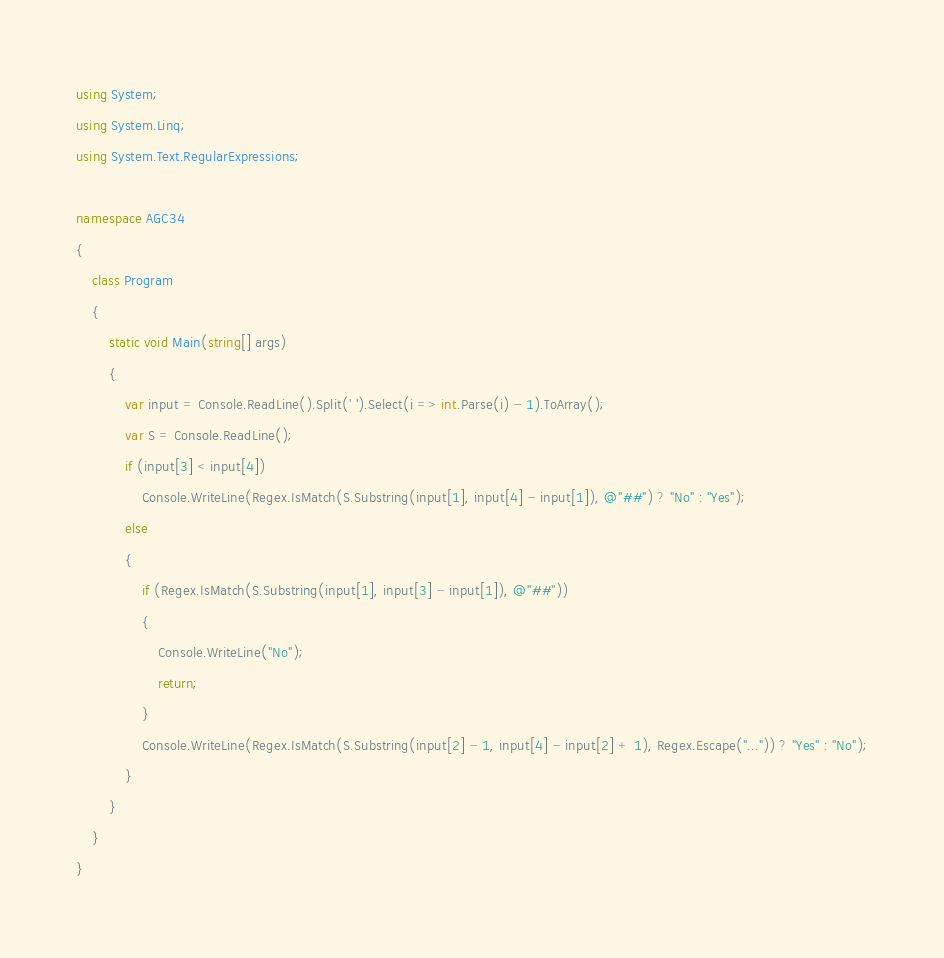<code> <loc_0><loc_0><loc_500><loc_500><_C#_>using System;
using System.Linq;
using System.Text.RegularExpressions;

namespace AGC34
{
    class Program
    {
        static void Main(string[] args)
        {
            var input = Console.ReadLine().Split(' ').Select(i => int.Parse(i) - 1).ToArray();
            var S = Console.ReadLine();
            if (input[3] < input[4])
                Console.WriteLine(Regex.IsMatch(S.Substring(input[1], input[4] - input[1]), @"##") ? "No" : "Yes");
            else
            {
                if (Regex.IsMatch(S.Substring(input[1], input[3] - input[1]), @"##"))
                {
                    Console.WriteLine("No");
                    return;
                }
                Console.WriteLine(Regex.IsMatch(S.Substring(input[2] - 1, input[4] - input[2] + 1), Regex.Escape("...")) ? "Yes" : "No");
            }
        }
    }
}
</code> 